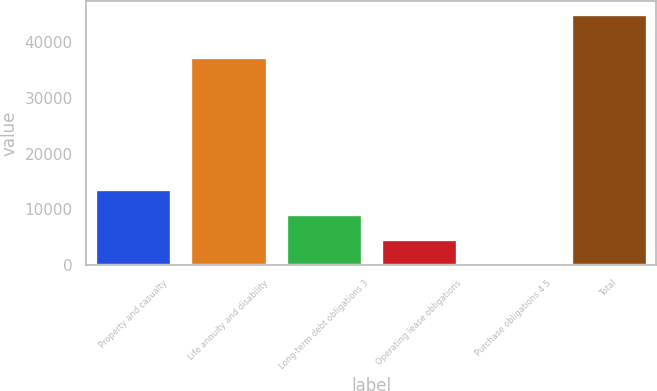<chart> <loc_0><loc_0><loc_500><loc_500><bar_chart><fcel>Property and casualty<fcel>Life annuity and disability<fcel>Long-term debt obligations 3<fcel>Operating lease obligations<fcel>Purchase obligations 4 5<fcel>Total<nl><fcel>13632.3<fcel>37318<fcel>9128.2<fcel>4624.1<fcel>120<fcel>45161<nl></chart> 